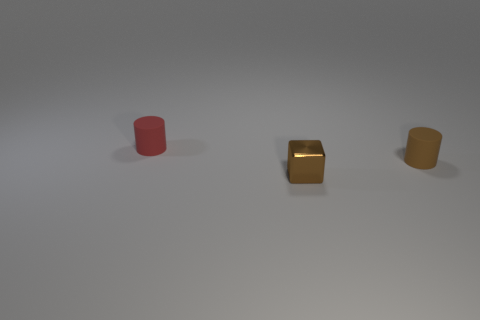Is there a brown cube of the same size as the red matte object?
Offer a terse response. Yes. Are there any tiny matte things of the same color as the cube?
Your answer should be very brief. Yes. What number of other things are the same color as the shiny object?
Make the answer very short. 1. Does the cube have the same color as the small rubber thing that is behind the brown matte thing?
Provide a succinct answer. No. How many things are large yellow matte blocks or cylinders that are right of the brown metallic thing?
Make the answer very short. 1. What size is the rubber cylinder that is left of the small rubber object that is in front of the red matte object?
Offer a very short reply. Small. Are there an equal number of small cylinders that are in front of the brown cylinder and small brown cubes in front of the brown metal block?
Your answer should be compact. Yes. Is there a block that is in front of the matte cylinder right of the small red object?
Give a very brief answer. Yes. The thing in front of the tiny rubber cylinder on the right side of the small red matte object is made of what material?
Provide a short and direct response. Metal. Is there a gray matte thing that has the same shape as the small red object?
Your response must be concise. No. 